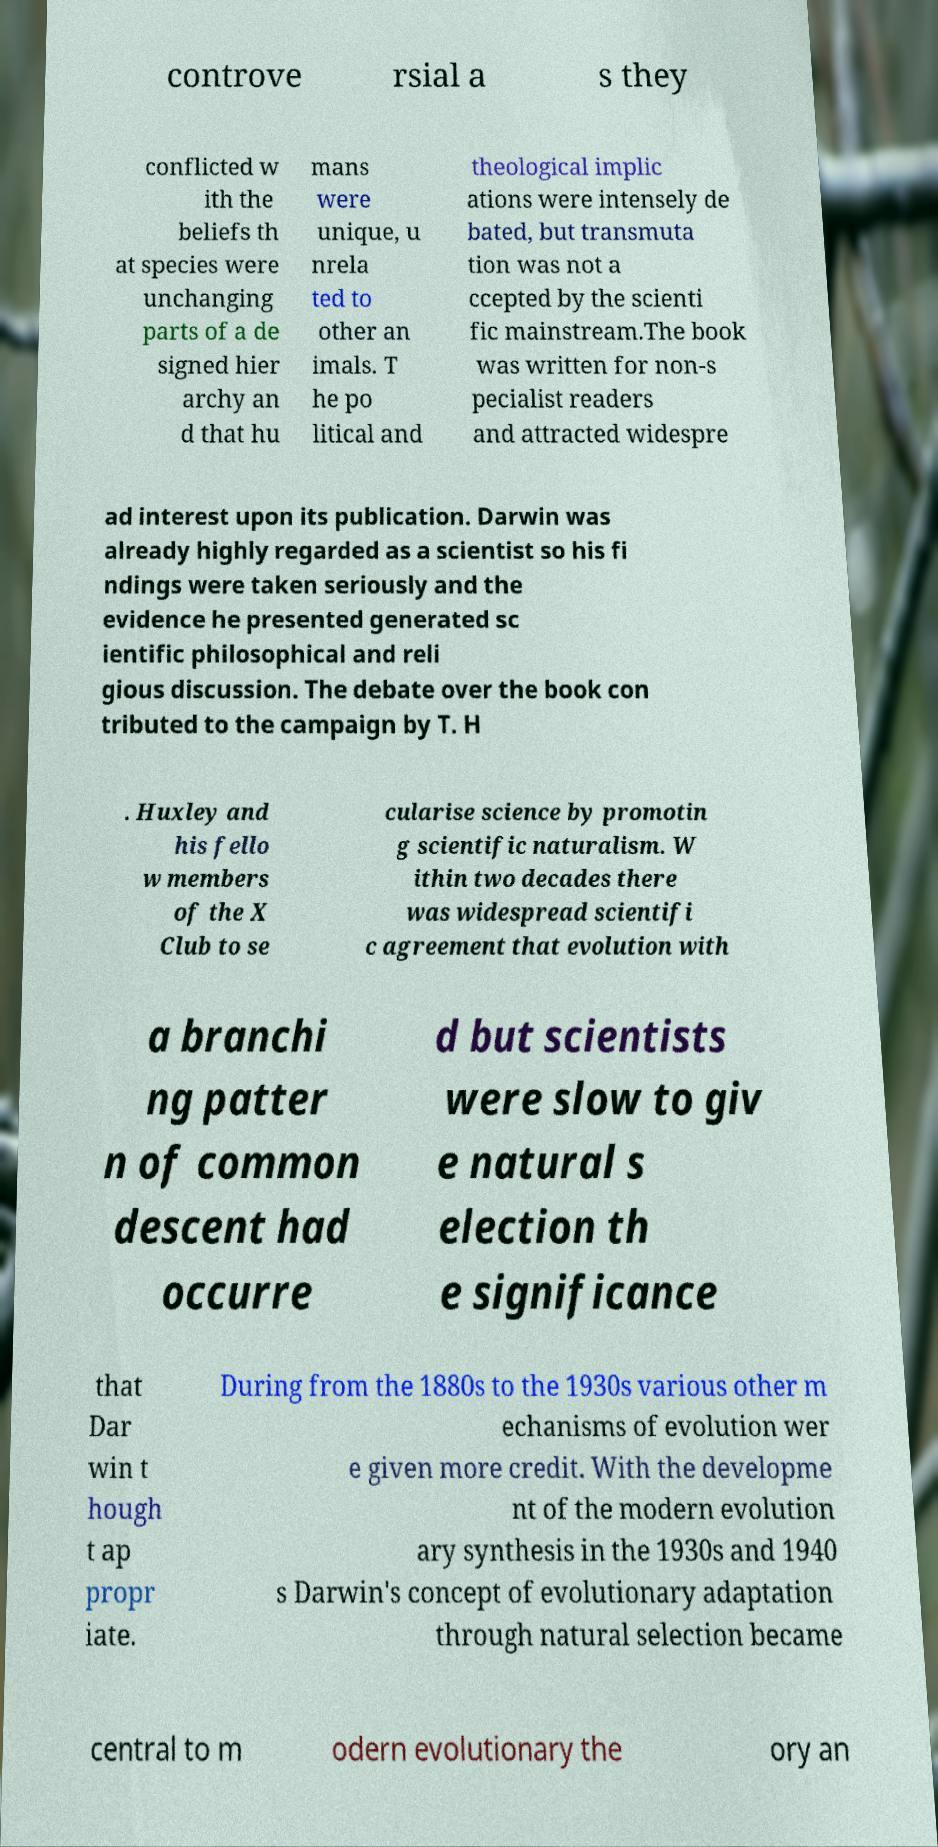Can you accurately transcribe the text from the provided image for me? controve rsial a s they conflicted w ith the beliefs th at species were unchanging parts of a de signed hier archy an d that hu mans were unique, u nrela ted to other an imals. T he po litical and theological implic ations were intensely de bated, but transmuta tion was not a ccepted by the scienti fic mainstream.The book was written for non-s pecialist readers and attracted widespre ad interest upon its publication. Darwin was already highly regarded as a scientist so his fi ndings were taken seriously and the evidence he presented generated sc ientific philosophical and reli gious discussion. The debate over the book con tributed to the campaign by T. H . Huxley and his fello w members of the X Club to se cularise science by promotin g scientific naturalism. W ithin two decades there was widespread scientifi c agreement that evolution with a branchi ng patter n of common descent had occurre d but scientists were slow to giv e natural s election th e significance that Dar win t hough t ap propr iate. During from the 1880s to the 1930s various other m echanisms of evolution wer e given more credit. With the developme nt of the modern evolution ary synthesis in the 1930s and 1940 s Darwin's concept of evolutionary adaptation through natural selection became central to m odern evolutionary the ory an 